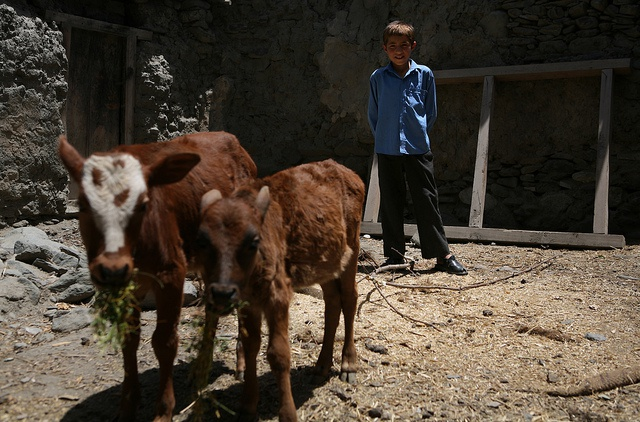Describe the objects in this image and their specific colors. I can see cow in black, maroon, and darkgray tones, cow in black, maroon, and gray tones, and people in black, navy, maroon, and gray tones in this image. 